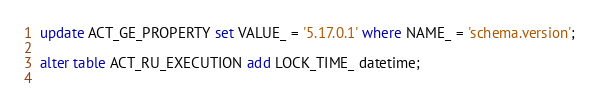Convert code to text. <code><loc_0><loc_0><loc_500><loc_500><_SQL_>update ACT_GE_PROPERTY set VALUE_ = '5.17.0.1' where NAME_ = 'schema.version';

alter table ACT_RU_EXECUTION add LOCK_TIME_ datetime;
	
</code> 